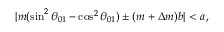Convert formula to latex. <formula><loc_0><loc_0><loc_500><loc_500>| m ( \sin ^ { 2 } \theta _ { 0 1 } - \cos ^ { 2 } \theta _ { 0 1 } ) \pm ( m + \Delta m ) b | < a \, ,</formula> 